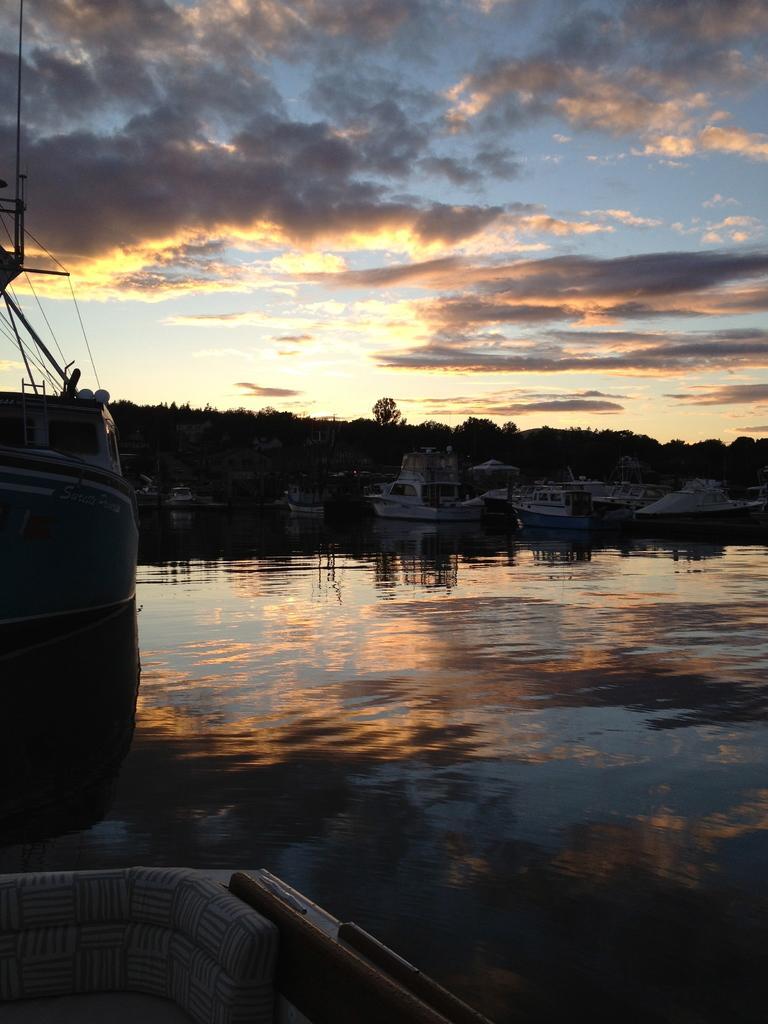Describe this image in one or two sentences. In this image, we can see so many boats are above the water. On the water, we can see some reflections. Background we can see so many trees and cloudy sky. 